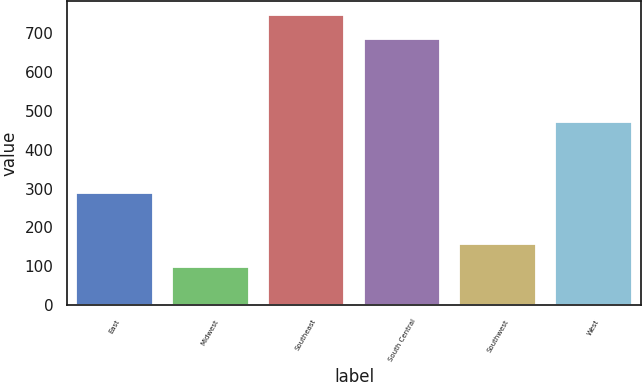<chart> <loc_0><loc_0><loc_500><loc_500><bar_chart><fcel>East<fcel>Midwest<fcel>Southeast<fcel>South Central<fcel>Southwest<fcel>West<nl><fcel>288.2<fcel>97<fcel>747.22<fcel>686.8<fcel>157.42<fcel>471.5<nl></chart> 